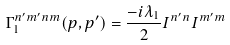<formula> <loc_0><loc_0><loc_500><loc_500>\Gamma _ { 1 } ^ { n ^ { \prime } m ^ { \prime } n m } ( p , p ^ { \prime } ) = \frac { - i \lambda _ { 1 } } { 2 } I ^ { n ^ { \prime } n } I ^ { m ^ { \prime } m }</formula> 